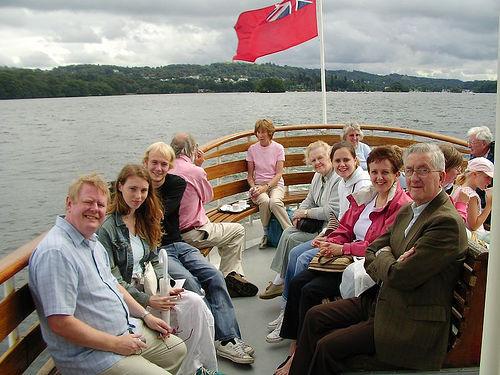Are these people on their way to visit the Moon?
Quick response, please. No. How many small kids are on the boat?
Quick response, please. 1. Is this group all together?
Short answer required. Yes. 